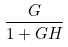Convert formula to latex. <formula><loc_0><loc_0><loc_500><loc_500>\frac { G } { 1 + G H }</formula> 